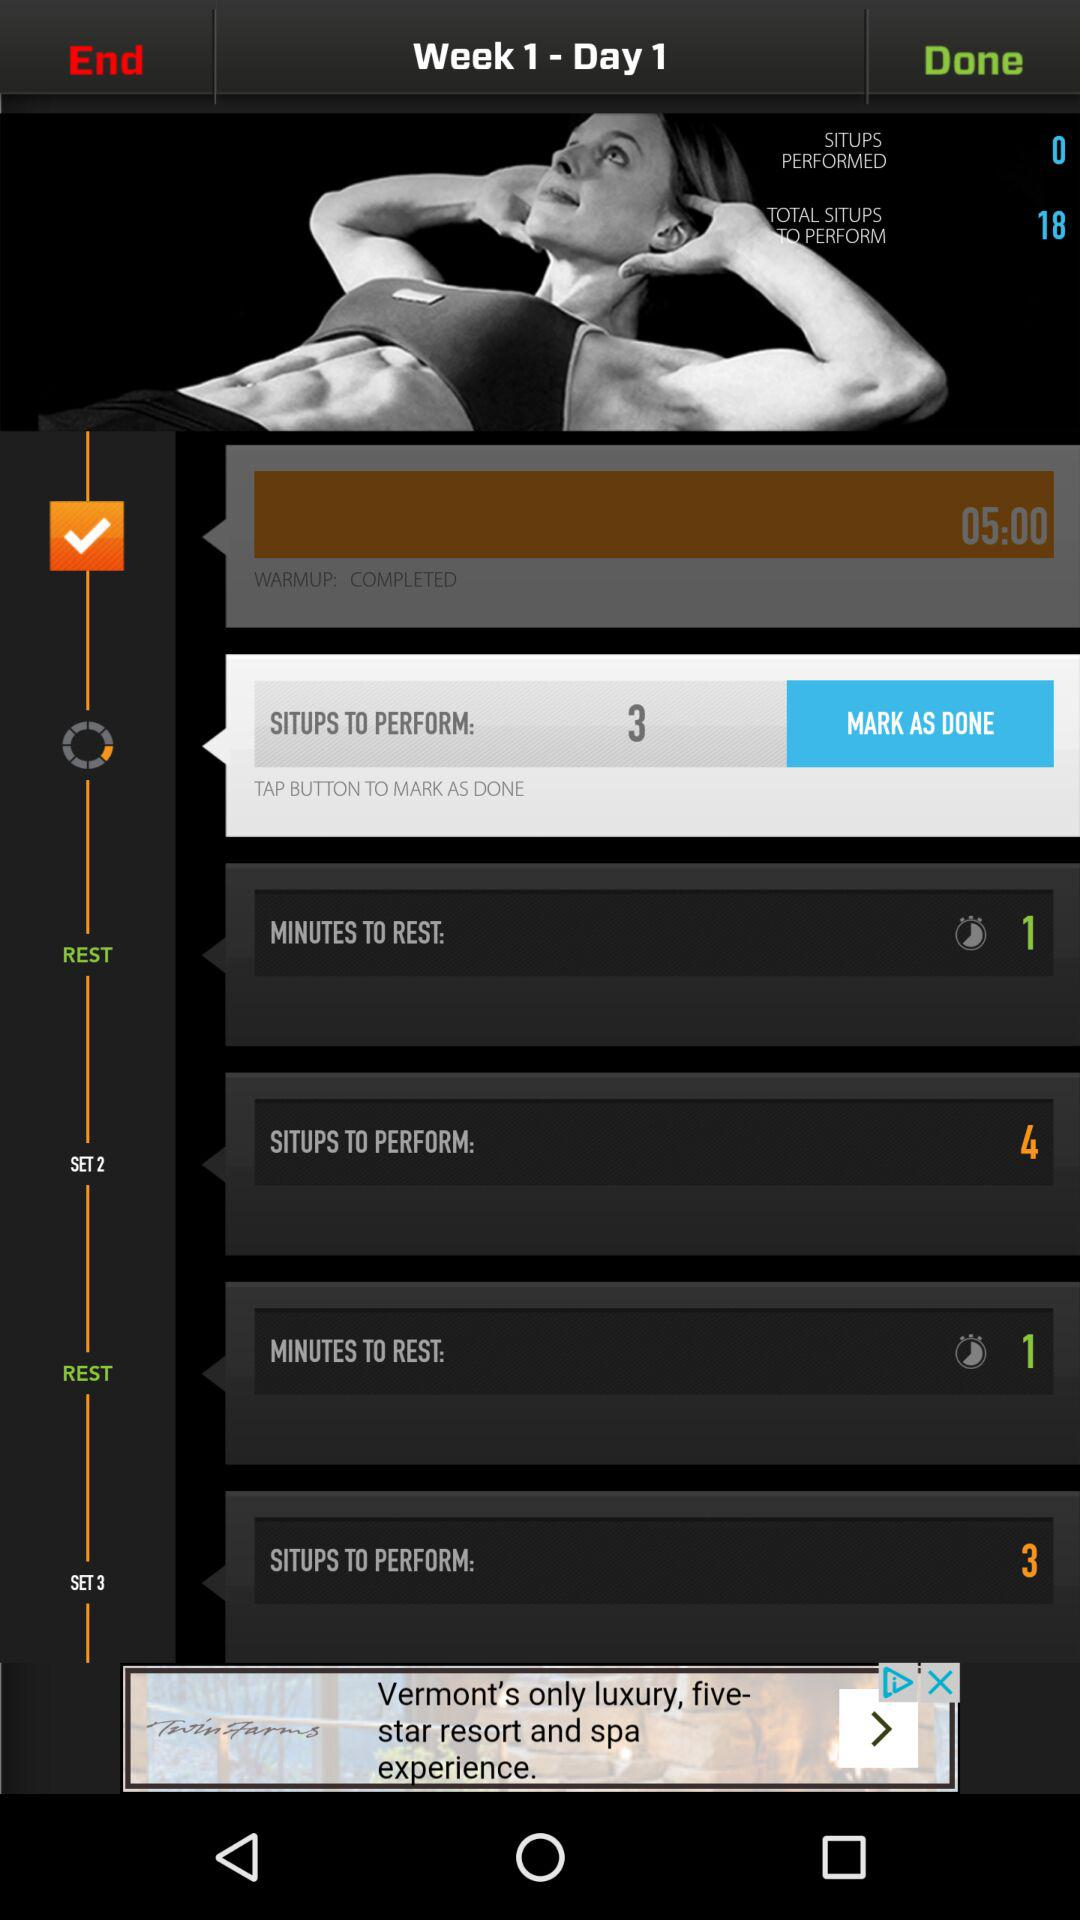What are the week and the day? The week is 1 and the day is 1. 